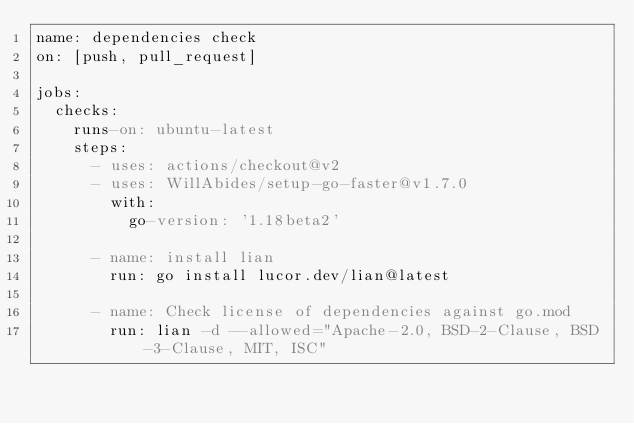Convert code to text. <code><loc_0><loc_0><loc_500><loc_500><_YAML_>name: dependencies check
on: [push, pull_request]

jobs:
  checks:
    runs-on: ubuntu-latest
    steps:
      - uses: actions/checkout@v2
      - uses: WillAbides/setup-go-faster@v1.7.0
        with:
          go-version: '1.18beta2'

      - name: install lian
        run: go install lucor.dev/lian@latest

      - name: Check license of dependencies against go.mod
        run: lian -d --allowed="Apache-2.0, BSD-2-Clause, BSD-3-Clause, MIT, ISC"</code> 